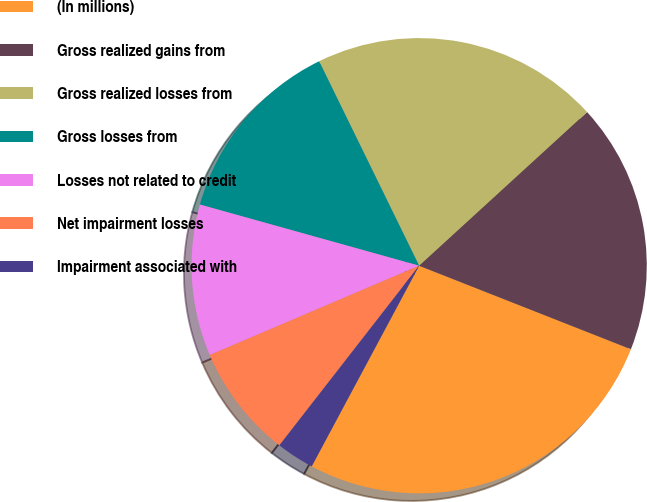<chart> <loc_0><loc_0><loc_500><loc_500><pie_chart><fcel>(In millions)<fcel>Gross realized gains from<fcel>Gross realized losses from<fcel>Gross losses from<fcel>Losses not related to credit<fcel>Net impairment losses<fcel>Impairment associated with<nl><fcel>26.85%<fcel>17.77%<fcel>20.45%<fcel>13.43%<fcel>10.75%<fcel>8.06%<fcel>2.7%<nl></chart> 